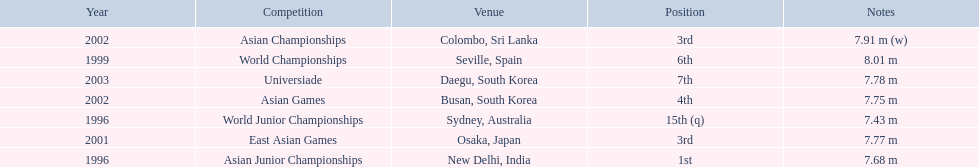What rankings has this competitor placed through the competitions? 15th (q), 1st, 6th, 3rd, 3rd, 4th, 7th. In which competition did the competitor place 1st? Asian Junior Championships. 